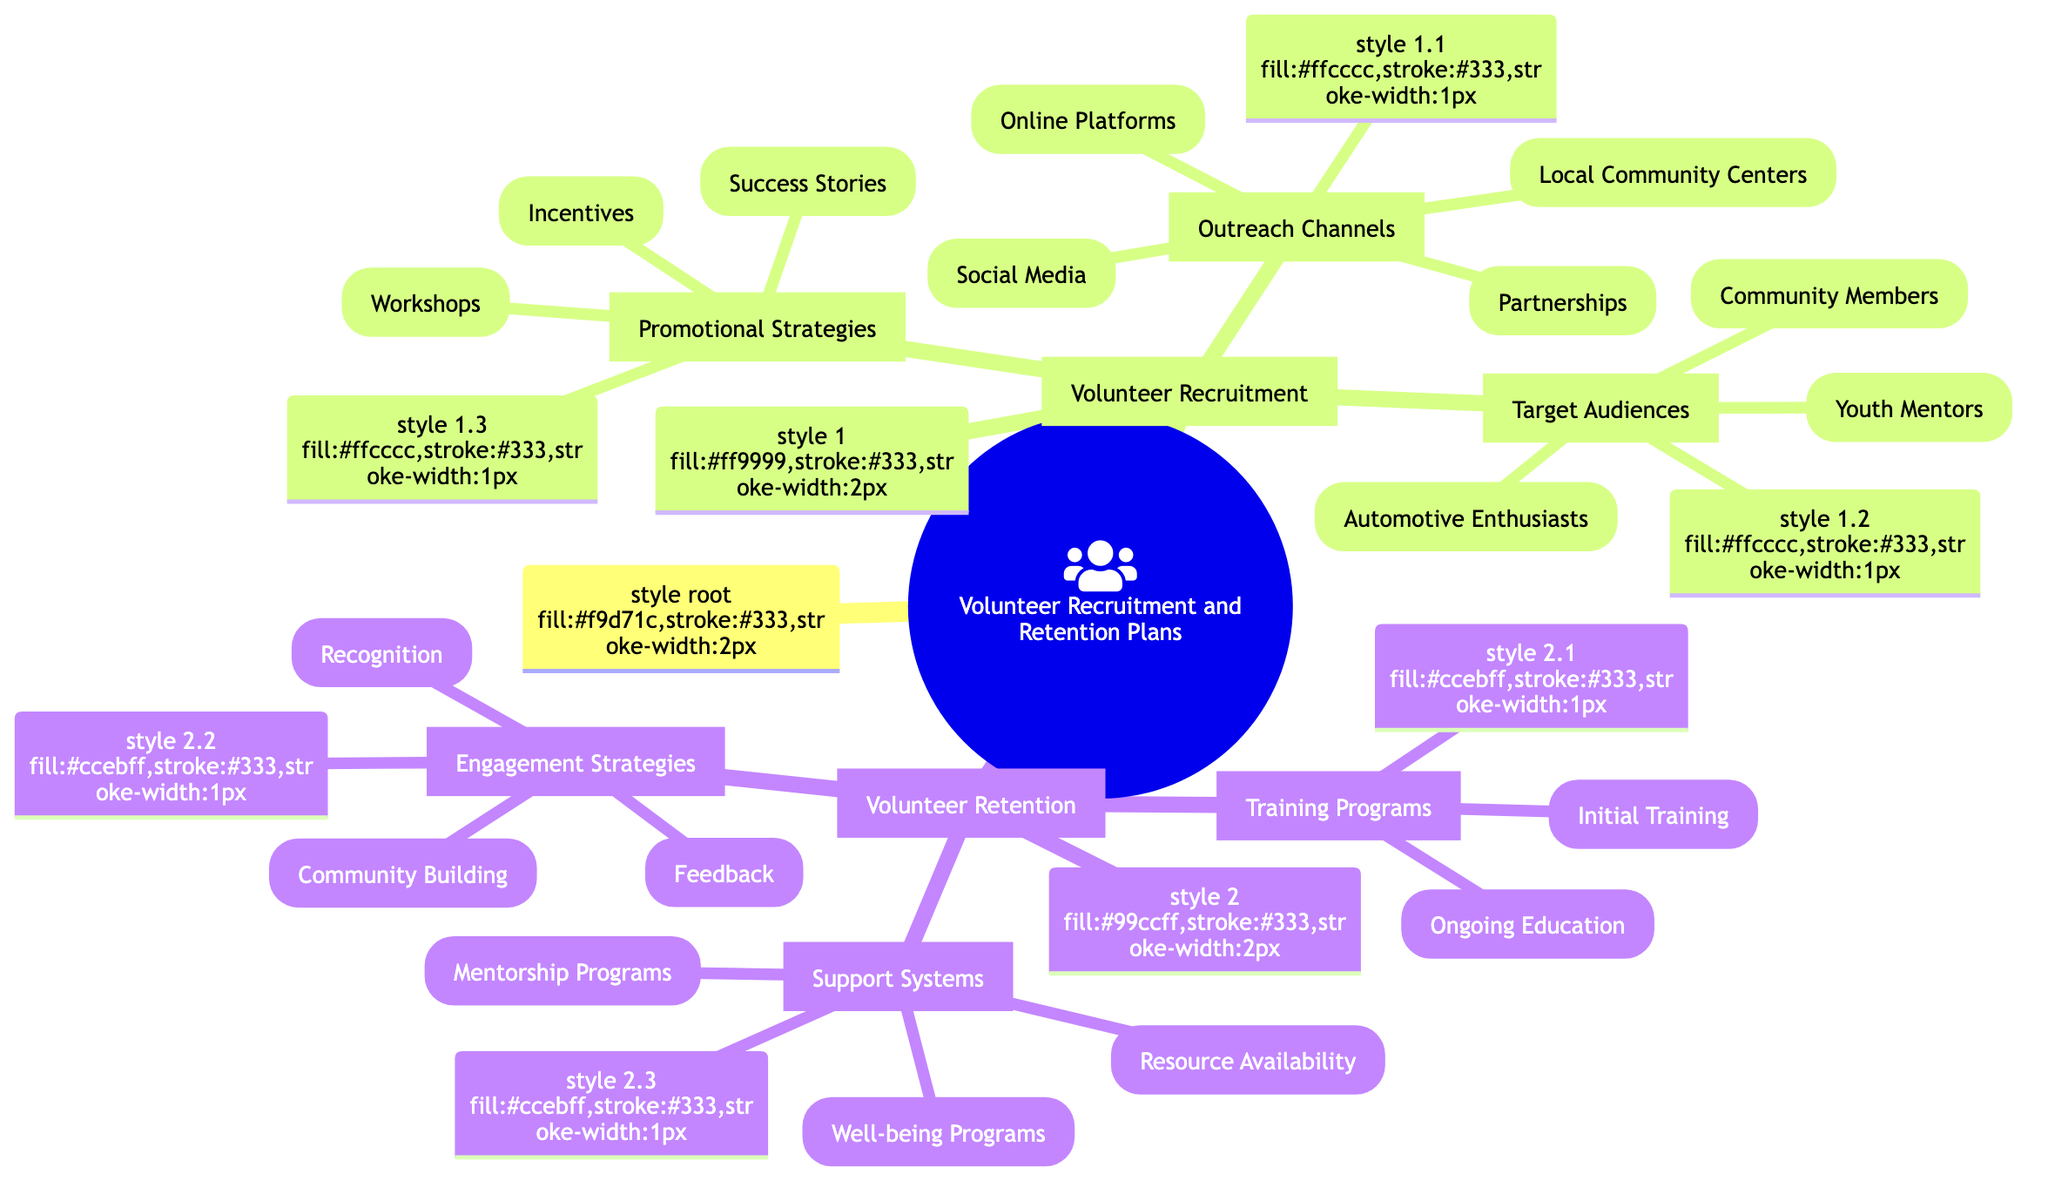What are the three main areas of focus in the mind map? The diagram consists of two main categories: "Volunteer Recruitment" and "Volunteer Retention." Each category covers various aspects essential for managing volunteers.
Answer: Volunteer Recruitment and Volunteer Retention How many outreach channels are listed under volunteer recruitment? Under the "Outreach Channels," there are four specific channels mentioned: Social Media, Local Community Centers, Partnerships, and Online Platforms. Therefore, the count is four.
Answer: 4 What audience group is targeted specifically for mentorship roles? Within the "Target Audiences," the group designated for mentorships is labeled "Youth Mentors," which includes retired professionals, technical experts, and automotive engineers.
Answer: Youth Mentors What promotional strategy involves sharing previous volunteer success? The promotional strategy aimed at sharing prior successes falls under "Success Stories," which comprises testimonials, before-and-after projects, and alumni spotlights.
Answer: Success Stories Which retention method involves direct communication with volunteers? The method focused on direct communication to gauge volunteer thoughts is termed "One-on-One Check-ins," which is part of the "Feedback" strategy under "Engagement Strategies."
Answer: One-on-One Check-ins How many types of training programs are there for volunteer retention? There are two distinct types of training programs categorized under "Training Programs": Initial Training and Ongoing Education.
Answer: 2 What recognition method involves social media engagement? The recognition method linked to social media is "Spotlight Features on Social Media," found within the "Recognition" section of the "Engagement Strategies."
Answer: Spotlight Features on Social Media What support system is focused on volunteer mental health? Under "Support Systems," the "Well-being Programs" category specifically includes initiatives that address mental health, providing valuable support for volunteers.
Answer: Well-being Programs What is one of the outreach channels specifically for local communities? One outreach channel dedicated to local communities is "Local Community Centers," where various methods like flyers and bulletin boards can be utilized.
Answer: Local Community Centers 